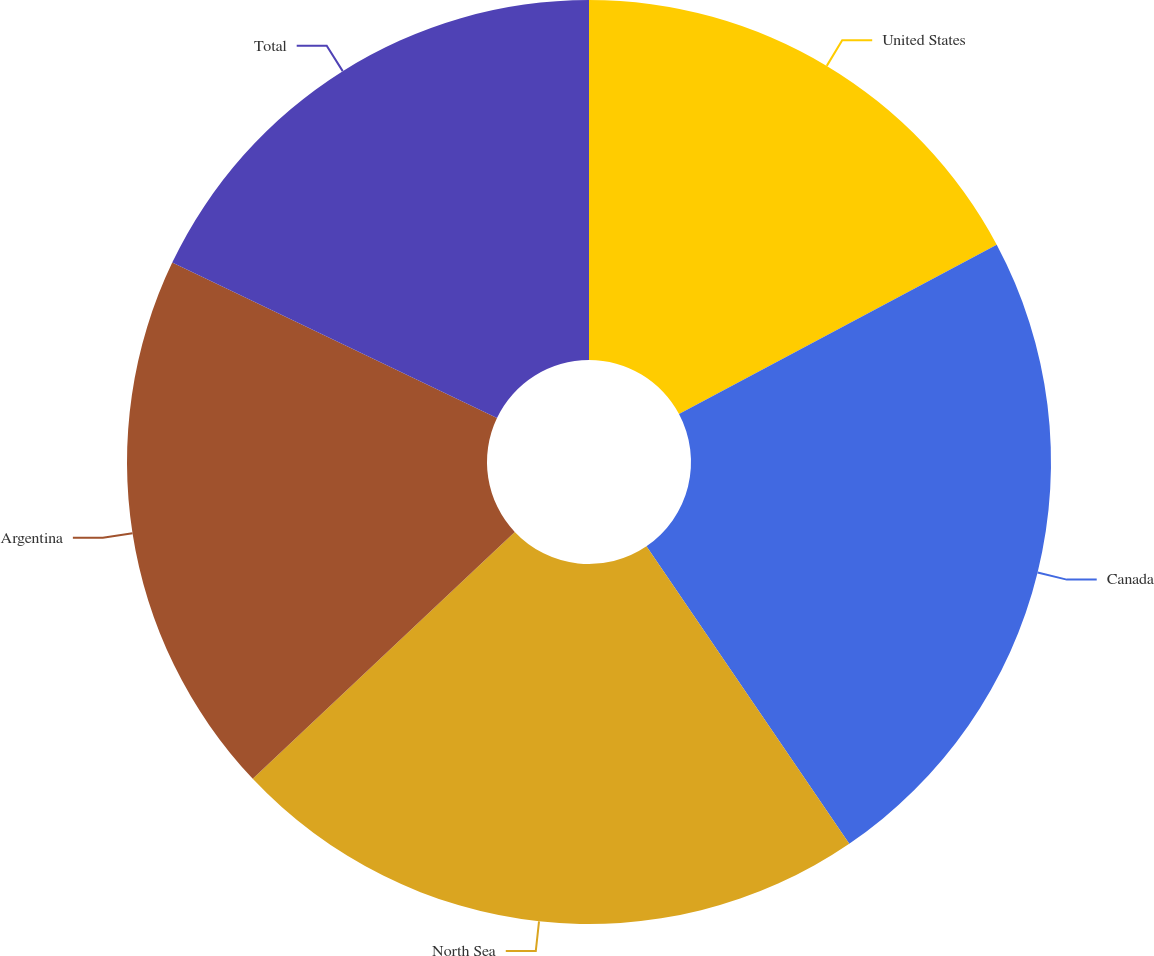<chart> <loc_0><loc_0><loc_500><loc_500><pie_chart><fcel>United States<fcel>Canada<fcel>North Sea<fcel>Argentina<fcel>Total<nl><fcel>17.21%<fcel>23.27%<fcel>22.5%<fcel>19.13%<fcel>17.9%<nl></chart> 